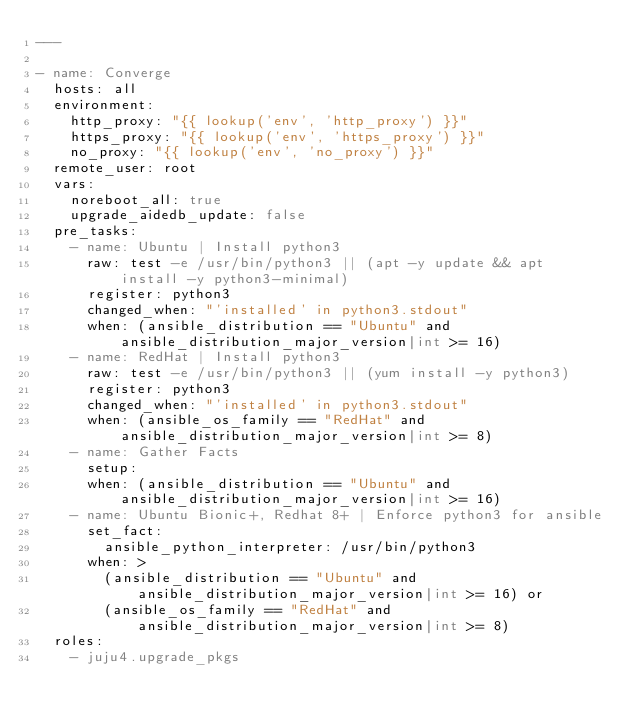<code> <loc_0><loc_0><loc_500><loc_500><_YAML_>---

- name: Converge
  hosts: all
  environment:
    http_proxy: "{{ lookup('env', 'http_proxy') }}"
    https_proxy: "{{ lookup('env', 'https_proxy') }}"
    no_proxy: "{{ lookup('env', 'no_proxy') }}"
  remote_user: root
  vars:
    noreboot_all: true
    upgrade_aidedb_update: false
  pre_tasks:
    - name: Ubuntu | Install python3
      raw: test -e /usr/bin/python3 || (apt -y update && apt install -y python3-minimal)
      register: python3
      changed_when: "'installed' in python3.stdout"
      when: (ansible_distribution == "Ubuntu" and ansible_distribution_major_version|int >= 16)
    - name: RedHat | Install python3
      raw: test -e /usr/bin/python3 || (yum install -y python3)
      register: python3
      changed_when: "'installed' in python3.stdout"
      when: (ansible_os_family == "RedHat" and ansible_distribution_major_version|int >= 8)
    - name: Gather Facts
      setup:
      when: (ansible_distribution == "Ubuntu" and ansible_distribution_major_version|int >= 16)
    - name: Ubuntu Bionic+, Redhat 8+ | Enforce python3 for ansible
      set_fact:
        ansible_python_interpreter: /usr/bin/python3
      when: >
        (ansible_distribution == "Ubuntu" and ansible_distribution_major_version|int >= 16) or
        (ansible_os_family == "RedHat" and ansible_distribution_major_version|int >= 8)
  roles:
    - juju4.upgrade_pkgs
</code> 